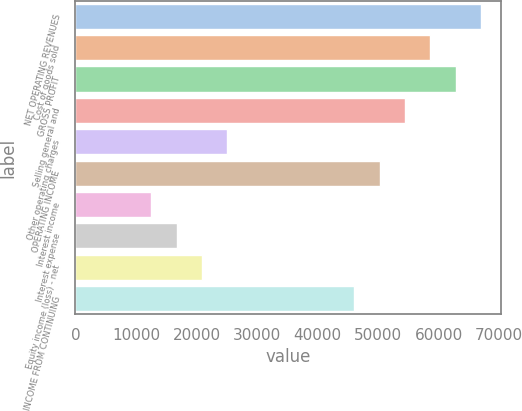<chart> <loc_0><loc_0><loc_500><loc_500><bar_chart><fcel>NET OPERATING REVENUES<fcel>Cost of goods sold<fcel>GROSS PROFIT<fcel>Selling general and<fcel>Other operating charges<fcel>OPERATING INCOME<fcel>Interest income<fcel>Interest expense<fcel>Equity income (loss) - net<fcel>INCOME FROM CONTINUING<nl><fcel>66979.9<fcel>58607.6<fcel>62793.7<fcel>54421.4<fcel>25118.4<fcel>50235.3<fcel>12559.9<fcel>16746.1<fcel>20932.2<fcel>46049.1<nl></chart> 